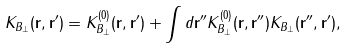<formula> <loc_0><loc_0><loc_500><loc_500>K _ { B _ { \perp } } ( { \mathbf r } , { \mathbf r } ^ { \prime } ) = K _ { B _ { \perp } } ^ { ( 0 ) } ( { \mathbf r } , { \mathbf r } ^ { \prime } ) + \int d { \mathbf r } ^ { \prime \prime } K _ { B _ { \perp } } ^ { ( 0 ) } ( { \mathbf r } , { \mathbf r } ^ { \prime \prime } ) K _ { B _ { \perp } } ( { \mathbf r } ^ { \prime \prime } , { \mathbf r } ^ { \prime } ) ,</formula> 